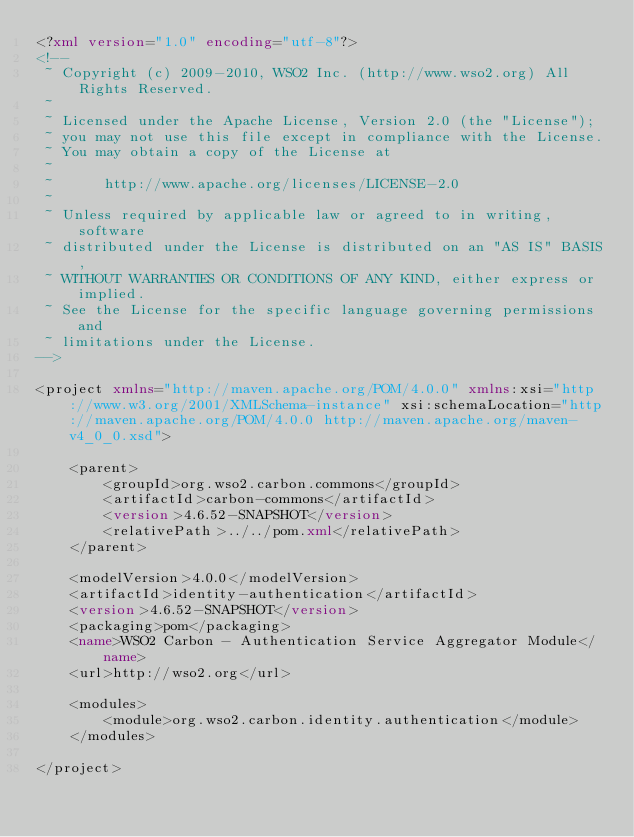<code> <loc_0><loc_0><loc_500><loc_500><_XML_><?xml version="1.0" encoding="utf-8"?>
<!--
 ~ Copyright (c) 2009-2010, WSO2 Inc. (http://www.wso2.org) All Rights Reserved.
 ~
 ~ Licensed under the Apache License, Version 2.0 (the "License");
 ~ you may not use this file except in compliance with the License.
 ~ You may obtain a copy of the License at
 ~
 ~      http://www.apache.org/licenses/LICENSE-2.0
 ~
 ~ Unless required by applicable law or agreed to in writing, software
 ~ distributed under the License is distributed on an "AS IS" BASIS,
 ~ WITHOUT WARRANTIES OR CONDITIONS OF ANY KIND, either express or implied.
 ~ See the License for the specific language governing permissions and
 ~ limitations under the License.
-->
        
<project xmlns="http://maven.apache.org/POM/4.0.0" xmlns:xsi="http://www.w3.org/2001/XMLSchema-instance" xsi:schemaLocation="http://maven.apache.org/POM/4.0.0 http://maven.apache.org/maven-v4_0_0.xsd">

    <parent>
        <groupId>org.wso2.carbon.commons</groupId>
        <artifactId>carbon-commons</artifactId>
        <version>4.6.52-SNAPSHOT</version>
        <relativePath>../../pom.xml</relativePath>
    </parent>

    <modelVersion>4.0.0</modelVersion>
    <artifactId>identity-authentication</artifactId>
    <version>4.6.52-SNAPSHOT</version>
    <packaging>pom</packaging>
    <name>WSO2 Carbon - Authentication Service Aggregator Module</name>
    <url>http://wso2.org</url>

    <modules>
        <module>org.wso2.carbon.identity.authentication</module>
    </modules>
    
</project>
</code> 